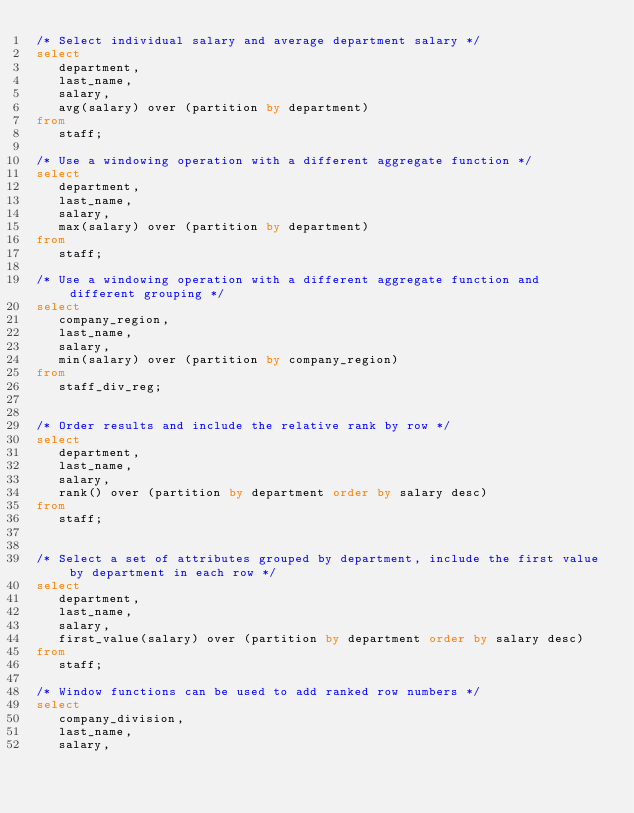Convert code to text. <code><loc_0><loc_0><loc_500><loc_500><_SQL_>/* Select individual salary and average department salary */
select
   department,
   last_name,
   salary,
   avg(salary) over (partition by department)
from
   staff;

/* Use a windowing operation with a different aggregate function */
select
   department,
   last_name,
   salary,
   max(salary) over (partition by department)
from
   staff;

/* Use a windowing operation with a different aggregate function and different grouping */
select
   company_region,
   last_name,
   salary,
   min(salary) over (partition by company_region)
from
   staff_div_reg;


/* Order results and include the relative rank by row */
select
   department,
   last_name,
   salary,
   rank() over (partition by department order by salary desc)
from
   staff;


/* Select a set of attributes grouped by department, include the first value by department in each row */
select
   department,
   last_name,
   salary,
   first_value(salary) over (partition by department order by salary desc)
from
   staff;

/* Window functions can be used to add ranked row numbers */
select
   company_division,
   last_name,
   salary,</code> 